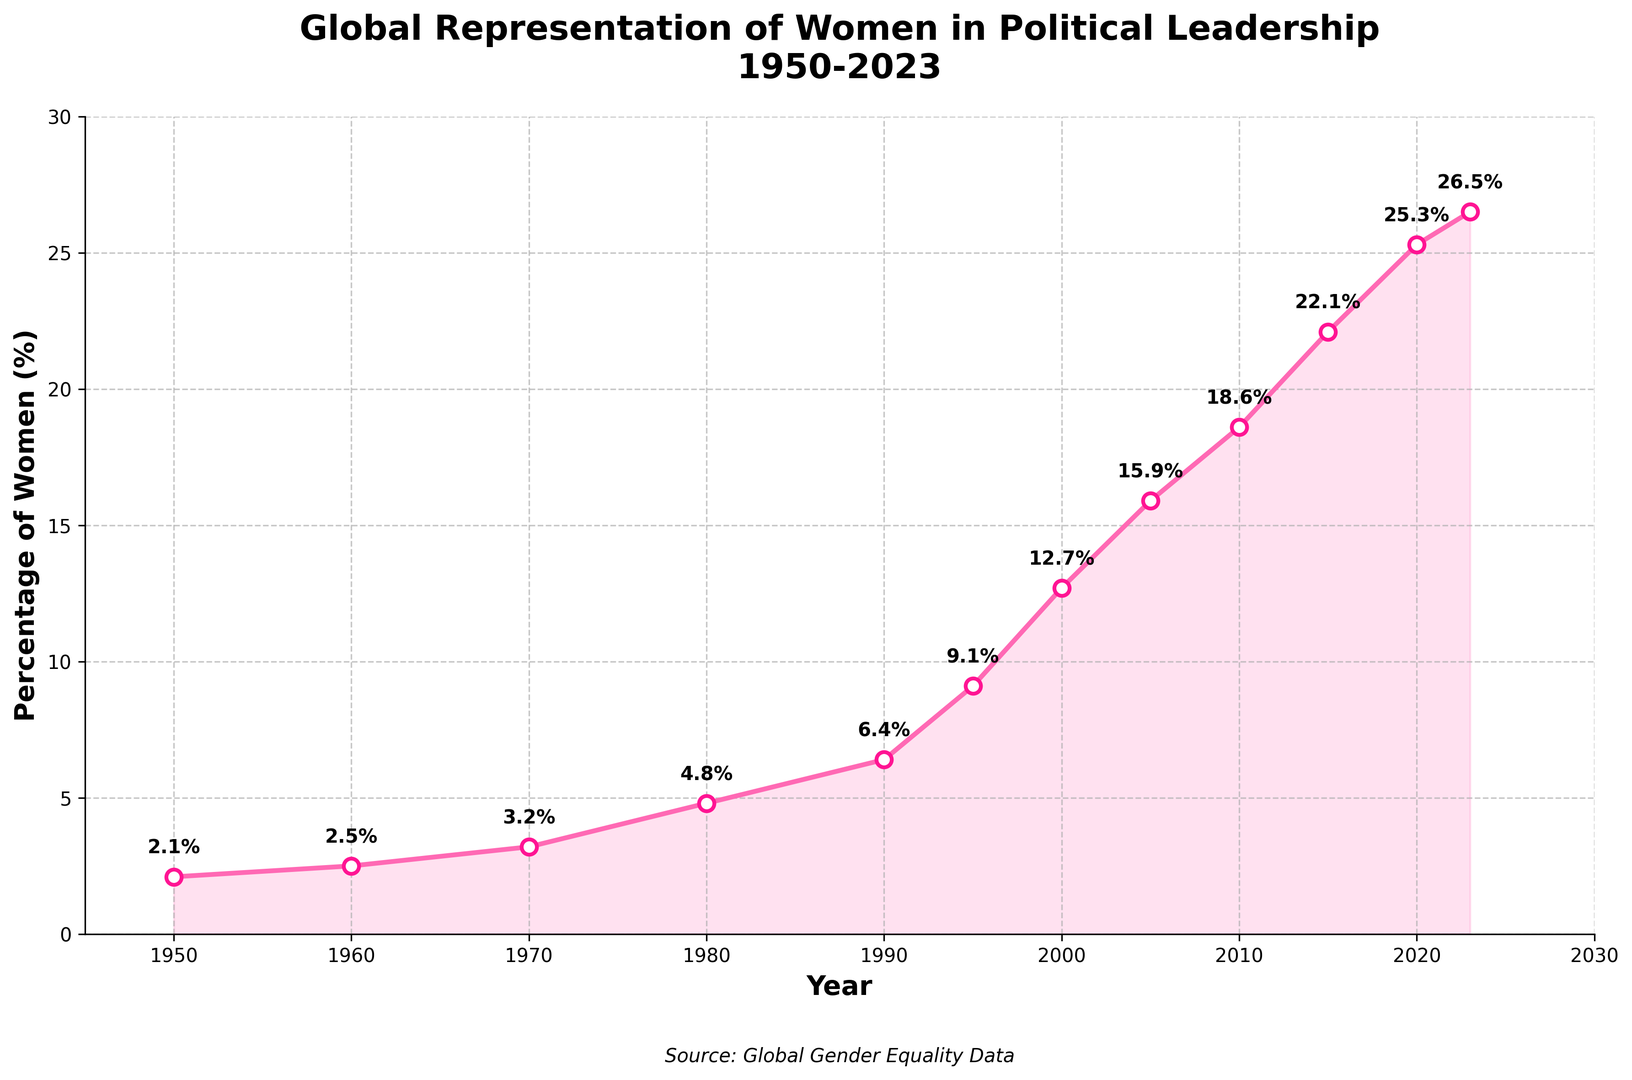What is the percentage increase in women's representation in political leadership from 1950 to 2023? To find the percentage increase, subtract the initial value in 1950 (2.1%) from the final value in 2023 (26.5%), then divide the result by the initial value and multiply by 100. Percentage increase = ((26.5 - 2.1) / 2.1) * 100
Answer: 1161.9% How many years did it take for the percentage of women in political leadership to reach double the value from 1950? The percentage in 1950 was 2.1%. Doubling this would be 4.2%. According to the chart, the first year exceeding 4.2% is 1980, which is 30 years after 1950
Answer: 30 years Between which consecutive decades was the highest growth in women's representation in political leadership recorded? Calculate the decade changes between each decade listed, from 1950 to 1960, 1960 to 1970, and so forth. The highest growth is observed between the years with the largest increase, which is from 2000 to 2005 (12.7% to 15.9%, an increase of 3.2%)
Answer: 2000 to 2005 What can you infer about the trend of women in political leadership positions from 1950 to 2023? The consistent upward trend in the line chart, with no decrease, indicates a steady increase in women's representation in political leadership positions globally over the period from 1950 to 2023
Answer: Steady increase In which years did the percentage of women in political leadership exceed 20%? By observing the chart, the years where the percentage exceeded 20% are 2015, 2020, and 2023
Answer: 2015, 2020, 2023 How does the percentage of women in political leadership positions in 2023 compare to that in 2000? In 2023, the percentage is 26.5%, compared to 12.7% in 2000. This indicates that the representation has more than doubled over this period
Answer: More than doubled Which year had the slowest growth in women's representation compared to the previous year? By comparing the increases between each consecutive data point, 1950 to 1960 increased by 0.4%, 1960 to 1970 by 0.7%, and so on. 1950-1960 had the smallest increase
Answer: 1950 to 1960 What visual features of the plot help indicate the growth trend over time? The upward slope of the line, the annotated percentage points at each year, and the filled area under the line (shaded in pink) visually communicate the increasing trend over time
Answer: Upward slope, annotations, shaded area 